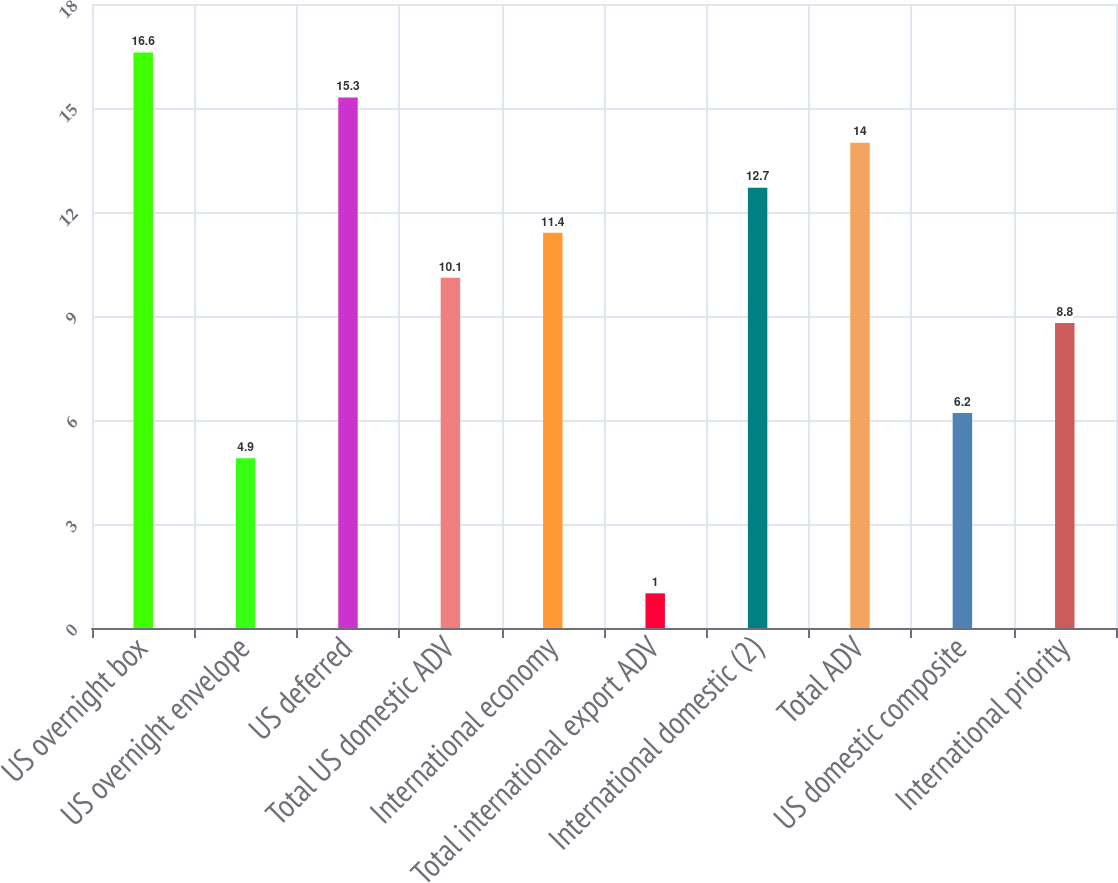Convert chart to OTSL. <chart><loc_0><loc_0><loc_500><loc_500><bar_chart><fcel>US overnight box<fcel>US overnight envelope<fcel>US deferred<fcel>Total US domestic ADV<fcel>International economy<fcel>Total international export ADV<fcel>International domestic (2)<fcel>Total ADV<fcel>US domestic composite<fcel>International priority<nl><fcel>16.6<fcel>4.9<fcel>15.3<fcel>10.1<fcel>11.4<fcel>1<fcel>12.7<fcel>14<fcel>6.2<fcel>8.8<nl></chart> 